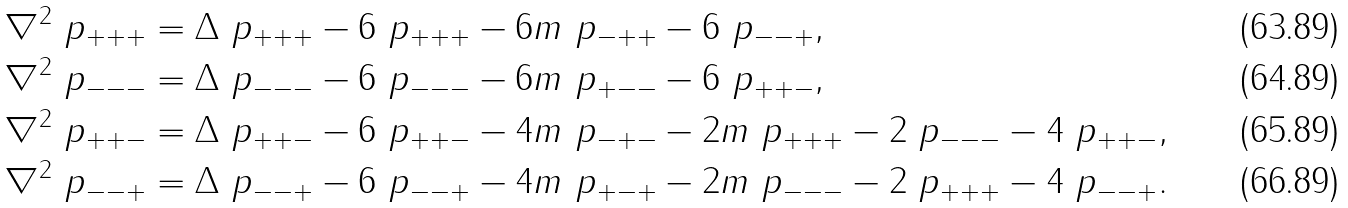Convert formula to latex. <formula><loc_0><loc_0><loc_500><loc_500>\nabla ^ { 2 } \ p _ { + + + } & = \Delta \ p _ { + + + } - 6 \ p _ { + + + } - 6 m \ p _ { - + + } - 6 \ p _ { - - + } , \\ \nabla ^ { 2 } \ p _ { - - - } & = \Delta \ p _ { - - - } - 6 \ p _ { - - - } - 6 m \ p _ { + - - } - 6 \ p _ { + + - } , \\ \nabla ^ { 2 } \ p _ { + + - } & = \Delta \ p _ { + + - } - 6 \ p _ { + + - } - 4 m \ p _ { - + - } - 2 m \ p _ { + + + } - 2 \ p _ { - - - } - 4 \ p _ { + + - } , \\ \nabla ^ { 2 } \ p _ { - - + } & = \Delta \ p _ { - - + } - 6 \ p _ { - - + } - 4 m \ p _ { + - + } - 2 m \ p _ { - - - } - 2 \ p _ { + + + } - 4 \ p _ { - - + } .</formula> 